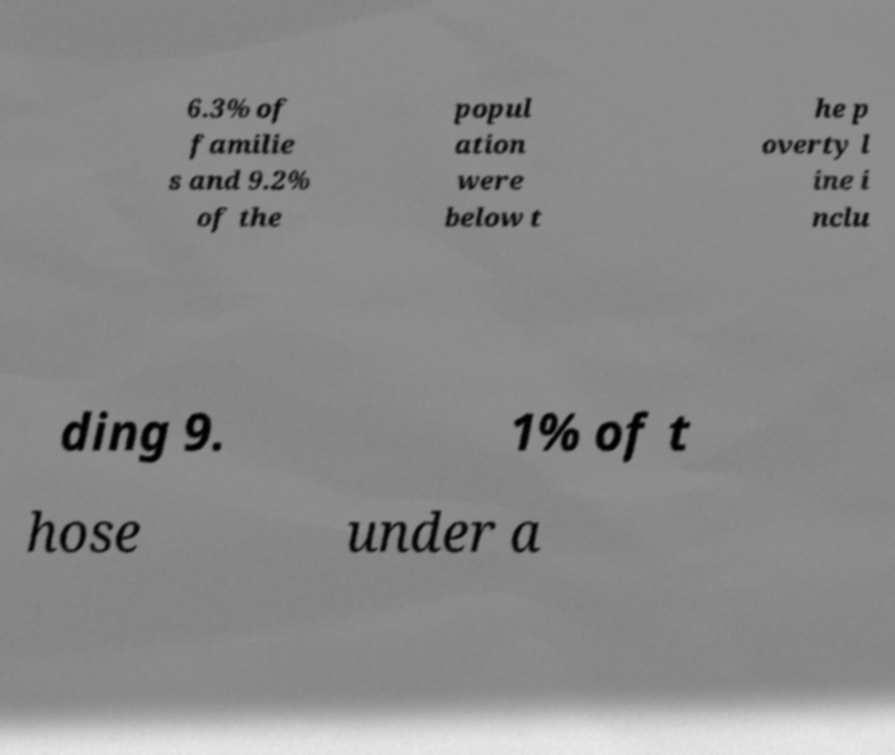Please read and relay the text visible in this image. What does it say? 6.3% of familie s and 9.2% of the popul ation were below t he p overty l ine i nclu ding 9. 1% of t hose under a 